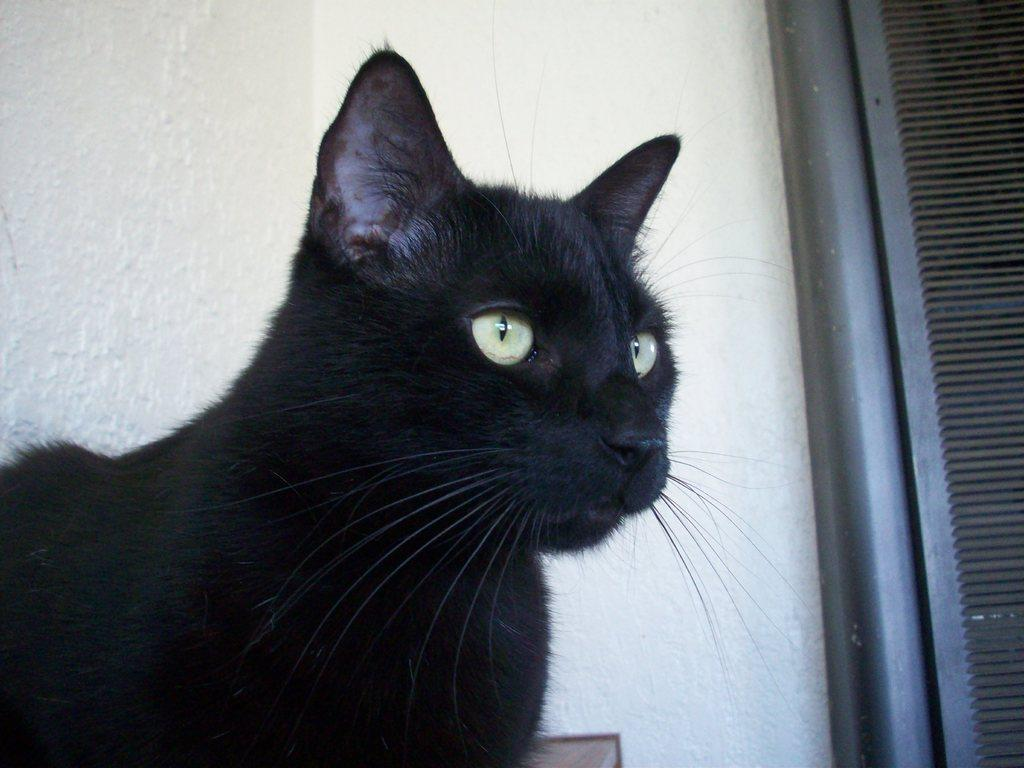What type of animal is on the left side of the image? There is a black cat on the left side of the image. What can be seen in the background of the image? There is a wall in the background of the image. What is located on the right side of the image? There is a rod and a metal object on the right side of the image. What type of dirt can be seen on the floor in the image? There is no dirt visible on the floor in the image. 